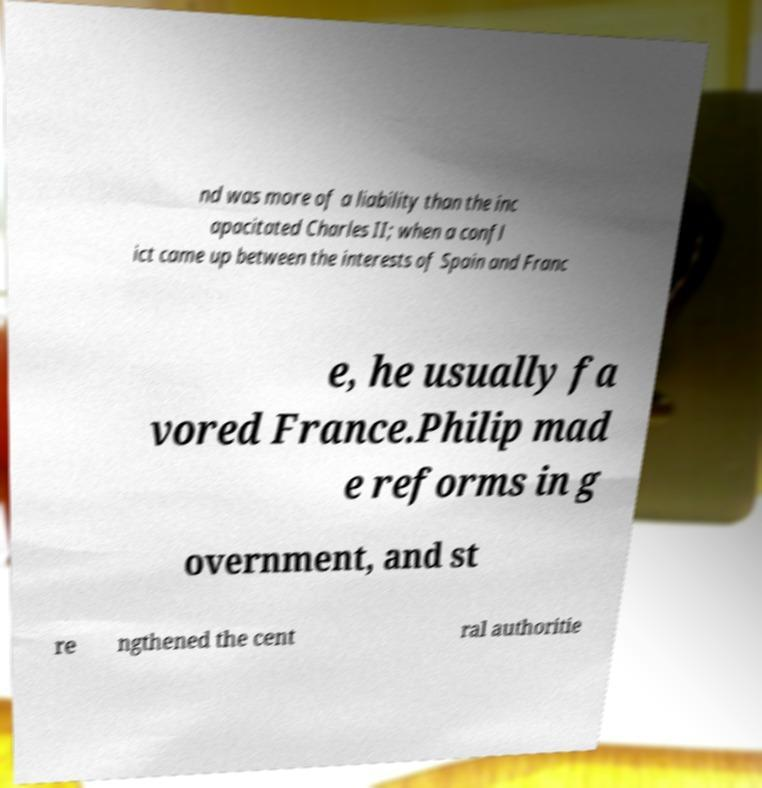Could you assist in decoding the text presented in this image and type it out clearly? nd was more of a liability than the inc apacitated Charles II; when a confl ict came up between the interests of Spain and Franc e, he usually fa vored France.Philip mad e reforms in g overnment, and st re ngthened the cent ral authoritie 